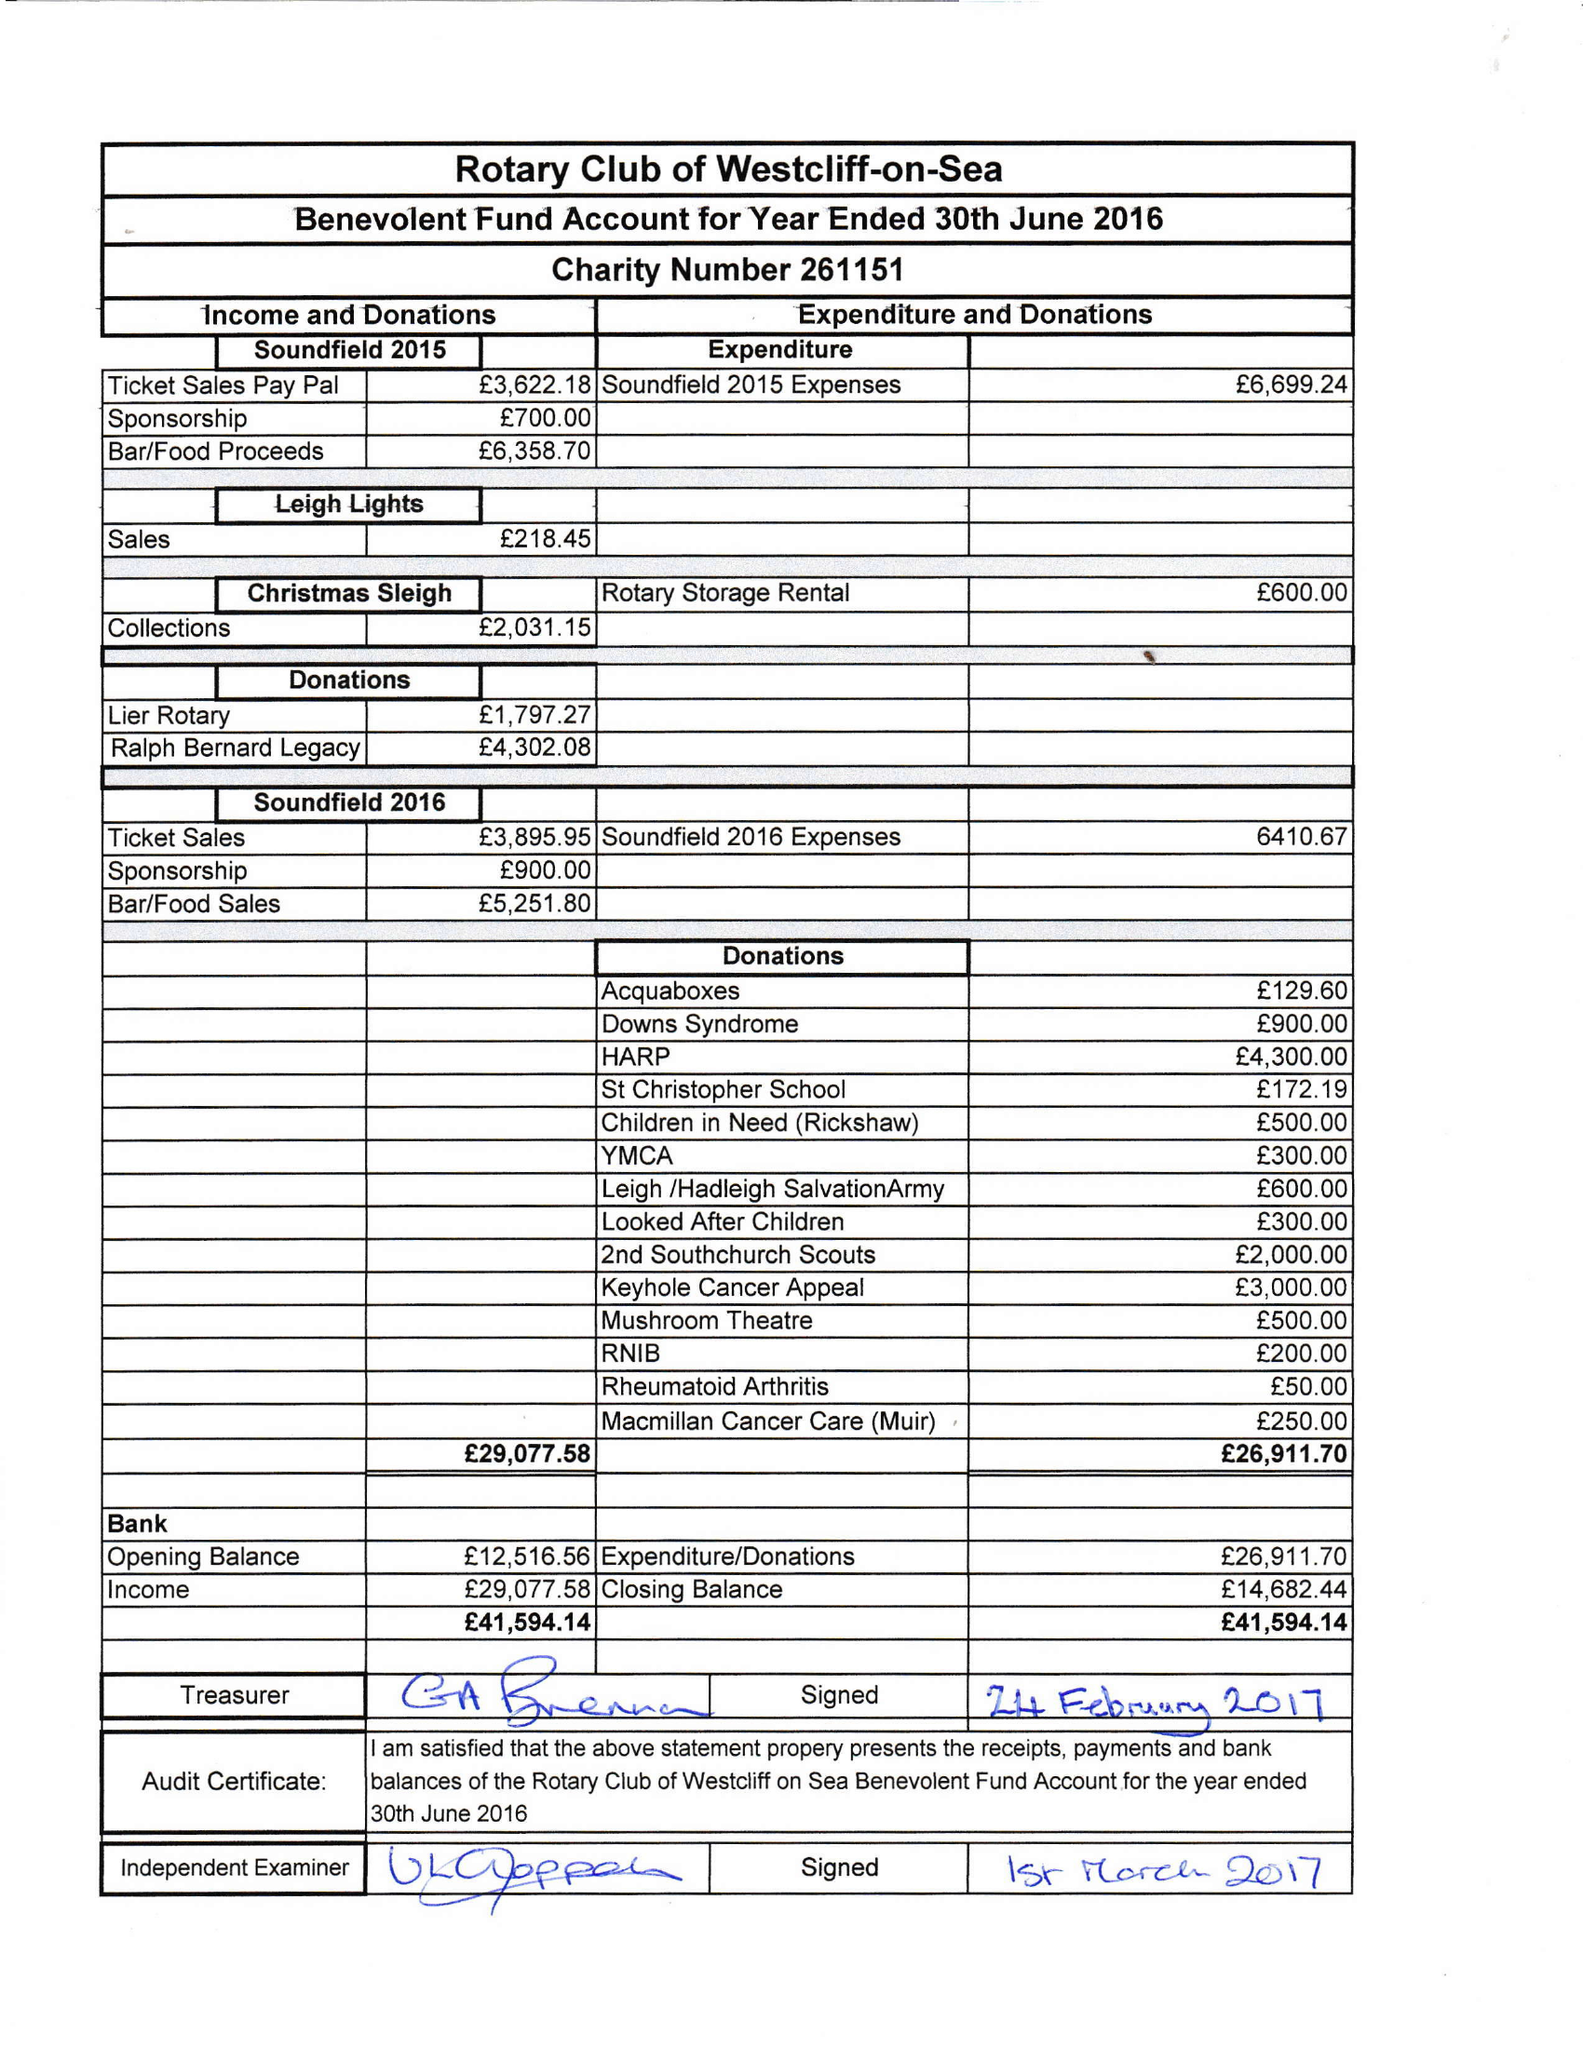What is the value for the income_annually_in_british_pounds?
Answer the question using a single word or phrase. 29078.00 